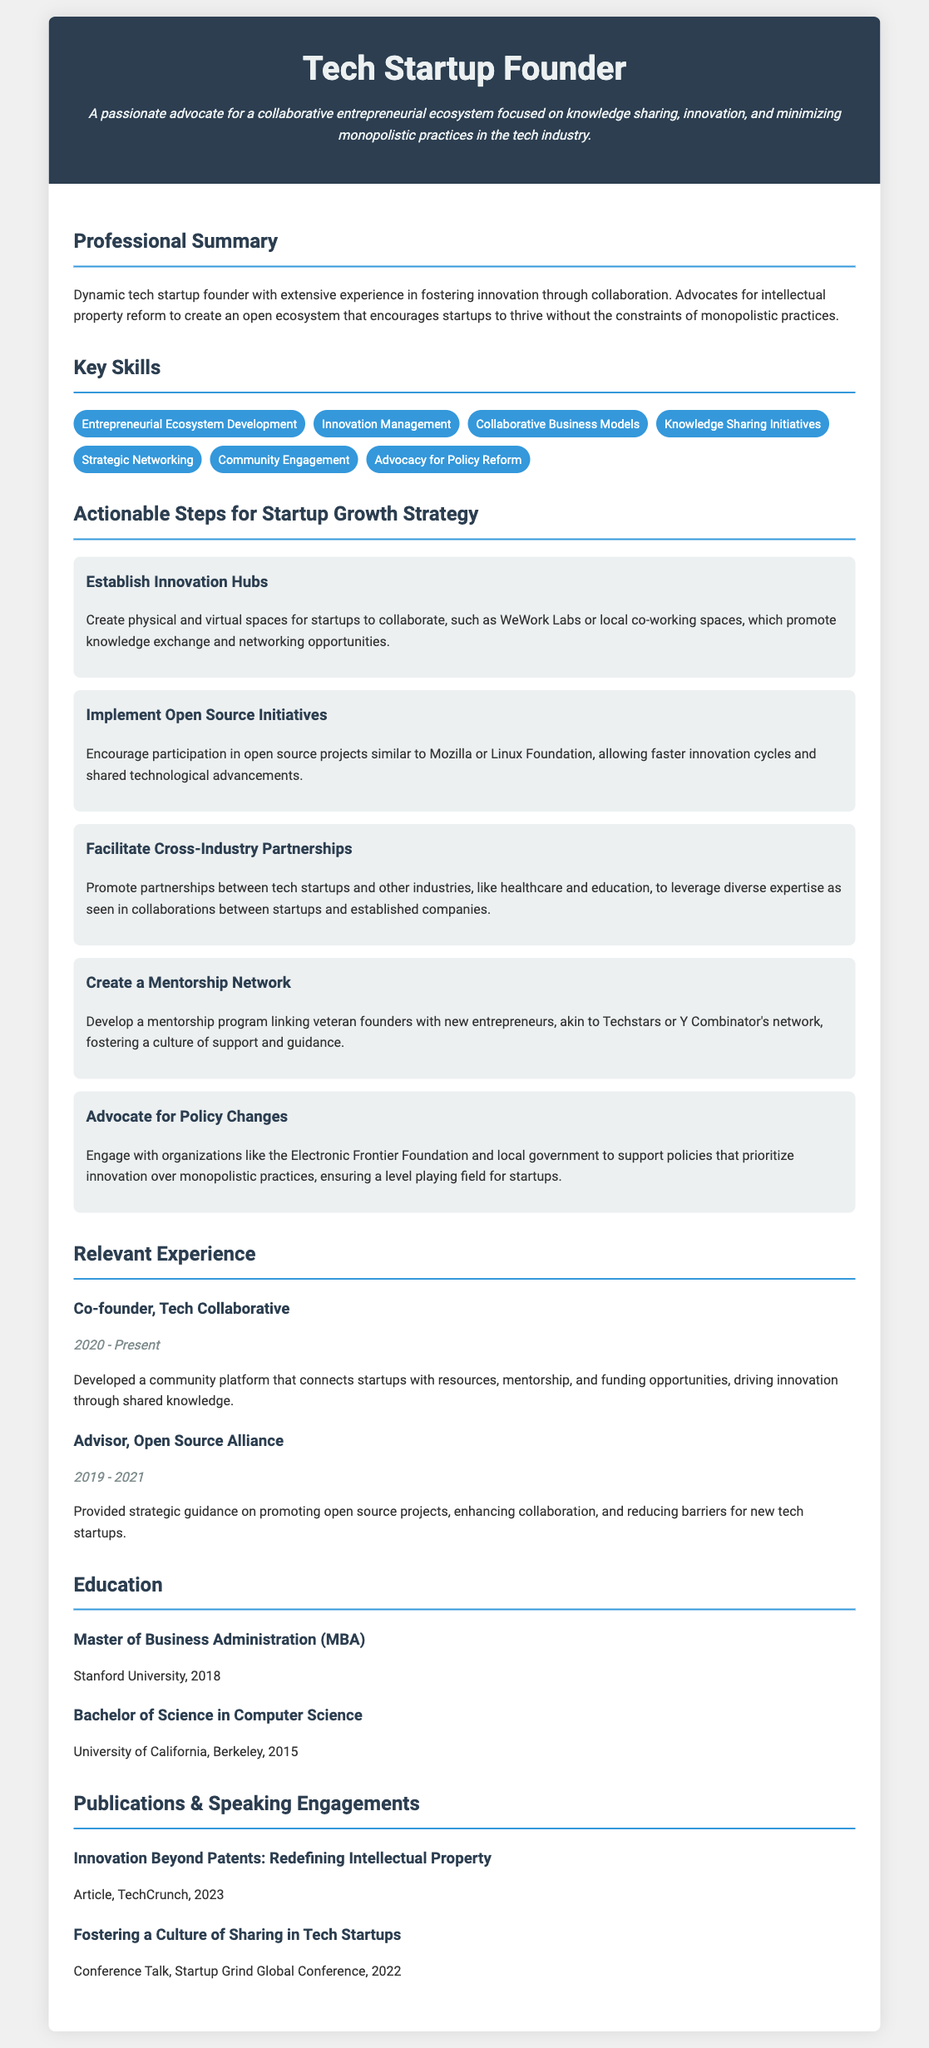What is the name of the founder? The document states the title at the top as "Tech Startup Founder".
Answer: Tech Startup Founder What year did they graduate with an MBA? The education section lists the MBA degree completion year as 2018.
Answer: 2018 What is one key skill mentioned in the document? The document lists multiple skills under "Key Skills", one of them is "Knowledge Sharing Initiatives".
Answer: Knowledge Sharing Initiatives What is the duration of the experience at Tech Collaborative? The duration listed next to the experience is from 2020 to Present.
Answer: 2020 - Present Which initiative encourages participation in open source projects? The actionable steps include "Implement Open Source Initiatives."
Answer: Implement Open Source Initiatives How many publications or speaking engagements are listed? The document shows two publications and speaking engagements in the section titled "Publications & Speaking Engagements".
Answer: Two What is the title of the article from TechCrunch? The document specifies "Innovation Beyond Patents: Redefining Intellectual Property" as the title of the article.
Answer: Innovation Beyond Patents: Redefining Intellectual Property What type of network is proposed to support new entrepreneurs? The step outlines the creation of a "Mentorship Network".
Answer: Mentorship Network What is emphasized as a way to reduce monopolistic practices? The document mentions "Advocate for Policy Changes" as a way to support this approach.
Answer: Advocate for Policy Changes 